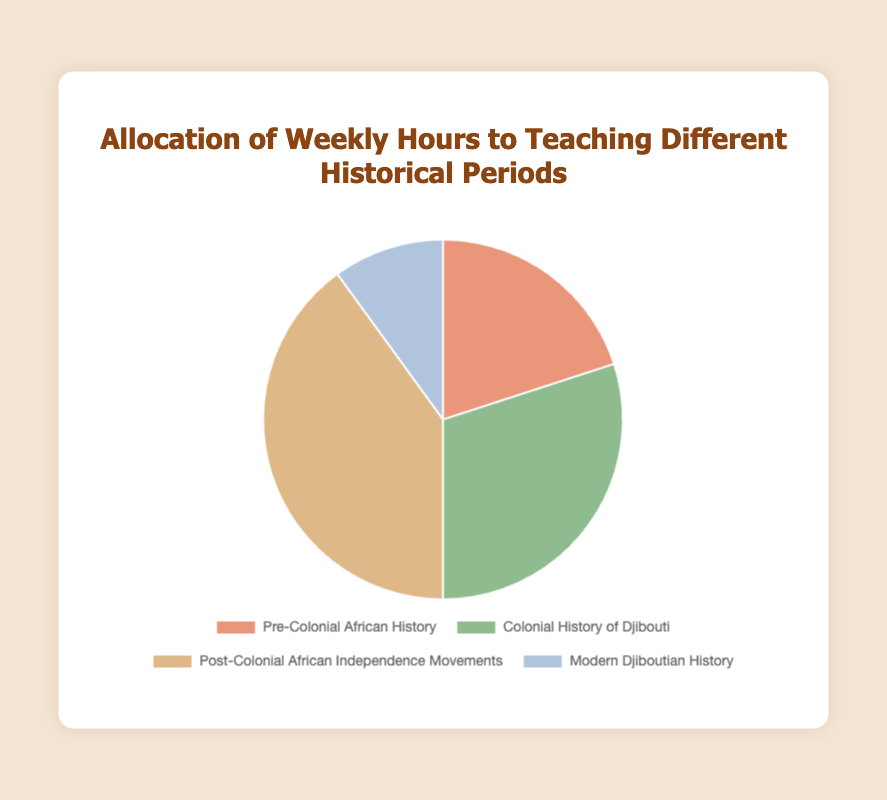What is the total number of hours allocated to teaching historical periods each week? Sum the hours for all four periods: 10 (Pre-Colonial African History) + 15 (Colonial History of Djibouti) + 20 (Post-Colonial African Independence Movements) + 5 (Modern Djiboutian History) = 50 hours
Answer: 50 hours Which historical period is allocated the most weekly hours? Identify the period with the highest number of hours. Post-Colonial African Independence Movements has 20 hours, which is the highest among the given periods
Answer: Post-Colonial African Independence Movements Which period has the least number of weekly teaching hours? Look for the period with the smallest number of hours. Modern Djiboutian History has 5 hours, which is the least
Answer: Modern Djiboutian History How many more hours are allocated to Colonial History of Djibouti compared to Modern Djiboutian History? Subtract the hours of Modern Djiboutian History from Colonial History of Djibouti: 15 - 5 = 10 hours
Answer: 10 hours What fraction of the total weekly teaching hours is allocated to Pre-Colonial African History? Divide the hours for Pre-Colonial African History by the total hours and convert to a fraction. 10 / 50 = 0.2 or 1/5
Answer: 1/5 How do the weekly hours for Pre-Colonial African History and Modern Djiboutian History compare? Compare the hours directly; Pre-Colonial African History has 10 hours and Modern Djiboutian History has 5 hours. 10 > 5
Answer: Pre-Colonial African History has more hours What is the combined total of hours for Colonial History of Djibouti and Modern Djiboutian History? Sum the hours for Colonial History of Djibouti and Modern Djiboutian History: 15 + 5 = 20 hours
Answer: 20 hours What percentage of the total weekly hours is dedicated to Post-Colonial African Independence Movements? Divide the hours for Post-Colonial African Independence Movements by the total hours and multiply by 100 to get the percentage. (20 / 50) * 100 = 40%
Answer: 40% What color represents Post-Colonial African Independence Movements in the pie chart? Identify the assigned color for Post-Colonial African Independence Movements from the chart. It's represented by the color "brown".
Answer: Brown 